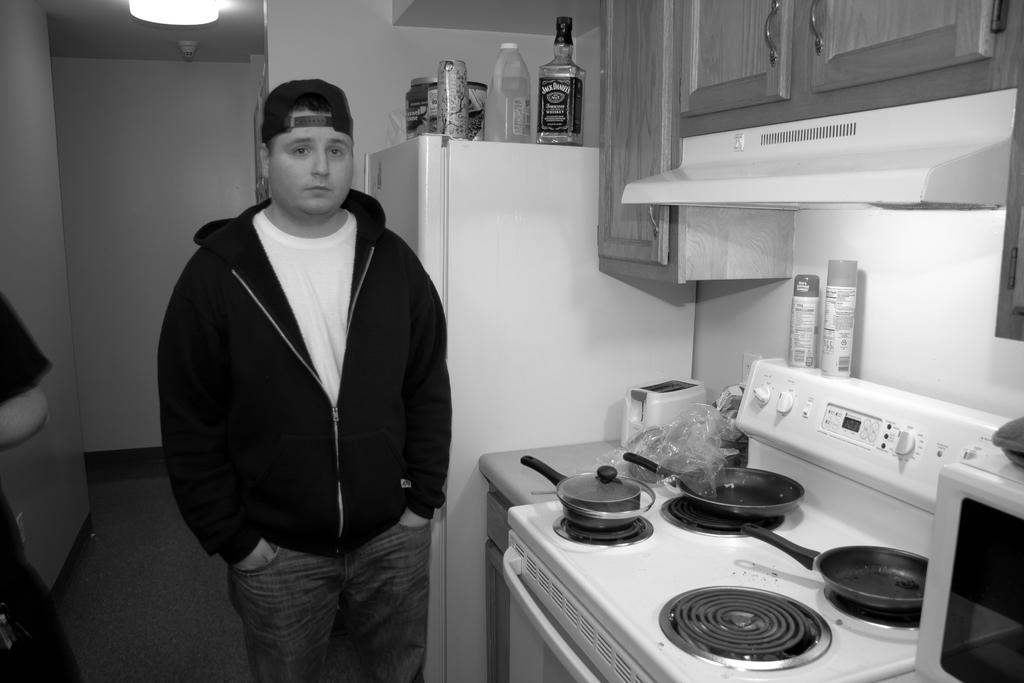Provide a one-sentence caption for the provided image. A man stands next to a fridge with a bottle of Jack Daniels on top of it. 